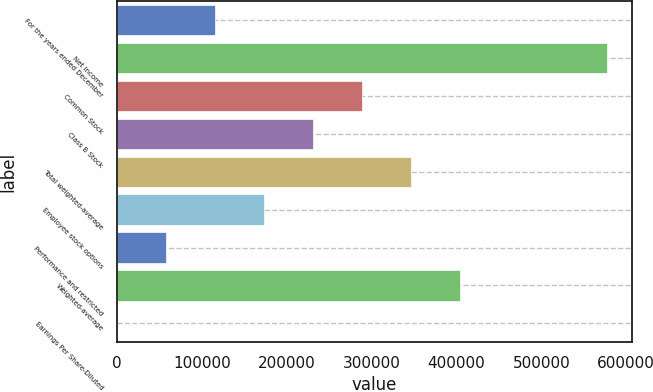Convert chart to OTSL. <chart><loc_0><loc_0><loc_500><loc_500><bar_chart><fcel>For the years ended December<fcel>Net income<fcel>Common Stock<fcel>Class B Stock<fcel>Total weighted-average<fcel>Employee stock options<fcel>Performance and restricted<fcel>Weighted-average<fcel>Earnings Per Share-Diluted<nl><fcel>115582<fcel>577901<fcel>288952<fcel>231162<fcel>346741<fcel>173372<fcel>57792.1<fcel>404531<fcel>2.25<nl></chart> 